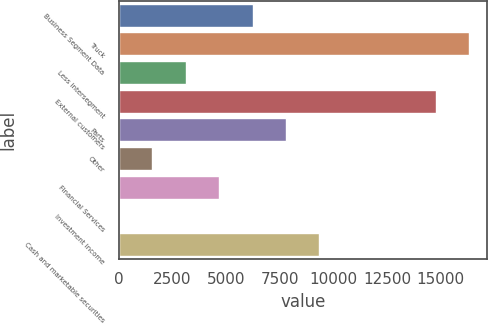Convert chart to OTSL. <chart><loc_0><loc_0><loc_500><loc_500><bar_chart><fcel>Business Segment Data<fcel>Truck<fcel>Less intersegment<fcel>External customers<fcel>Parts<fcel>Other<fcel>Financial Services<fcel>Investment income<fcel>Cash and marketable securities<nl><fcel>6240.52<fcel>16337.2<fcel>3131.16<fcel>14782.5<fcel>7795.2<fcel>1576.48<fcel>4685.84<fcel>21.8<fcel>9349.88<nl></chart> 